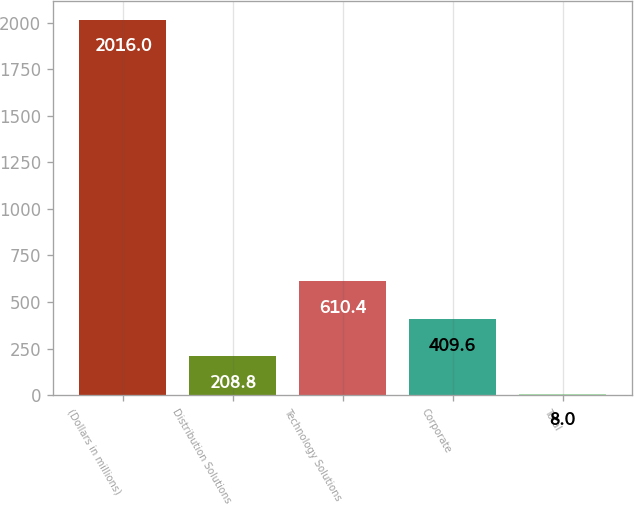Convert chart to OTSL. <chart><loc_0><loc_0><loc_500><loc_500><bar_chart><fcel>(Dollars in millions)<fcel>Distribution Solutions<fcel>Technology Solutions<fcel>Corporate<fcel>Total<nl><fcel>2016<fcel>208.8<fcel>610.4<fcel>409.6<fcel>8<nl></chart> 